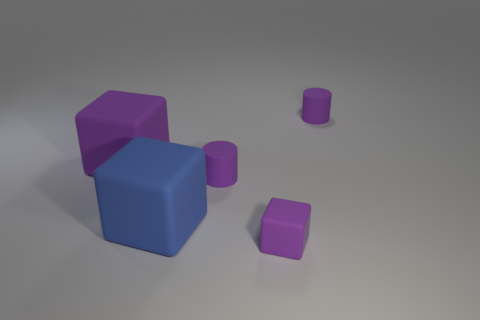What number of other objects are there of the same size as the blue object?
Offer a terse response. 1. What shape is the large thing in front of the purple matte cylinder that is to the left of the tiny block?
Your answer should be compact. Cube. Is the color of the large cube behind the large blue rubber thing the same as the tiny rubber cylinder that is in front of the big purple object?
Offer a very short reply. Yes. Are there any other things of the same color as the tiny block?
Your answer should be very brief. Yes. What is the color of the tiny cube?
Offer a terse response. Purple. Are any tiny gray shiny balls visible?
Provide a succinct answer. No. Are there any matte cylinders in front of the big blue block?
Give a very brief answer. No. Is there any other thing that has the same material as the big blue thing?
Your response must be concise. Yes. What number of other things are the same shape as the blue object?
Your answer should be compact. 2. How many small purple cylinders are on the left side of the large purple matte block that is behind the rubber cylinder left of the small rubber cube?
Your answer should be compact. 0. 